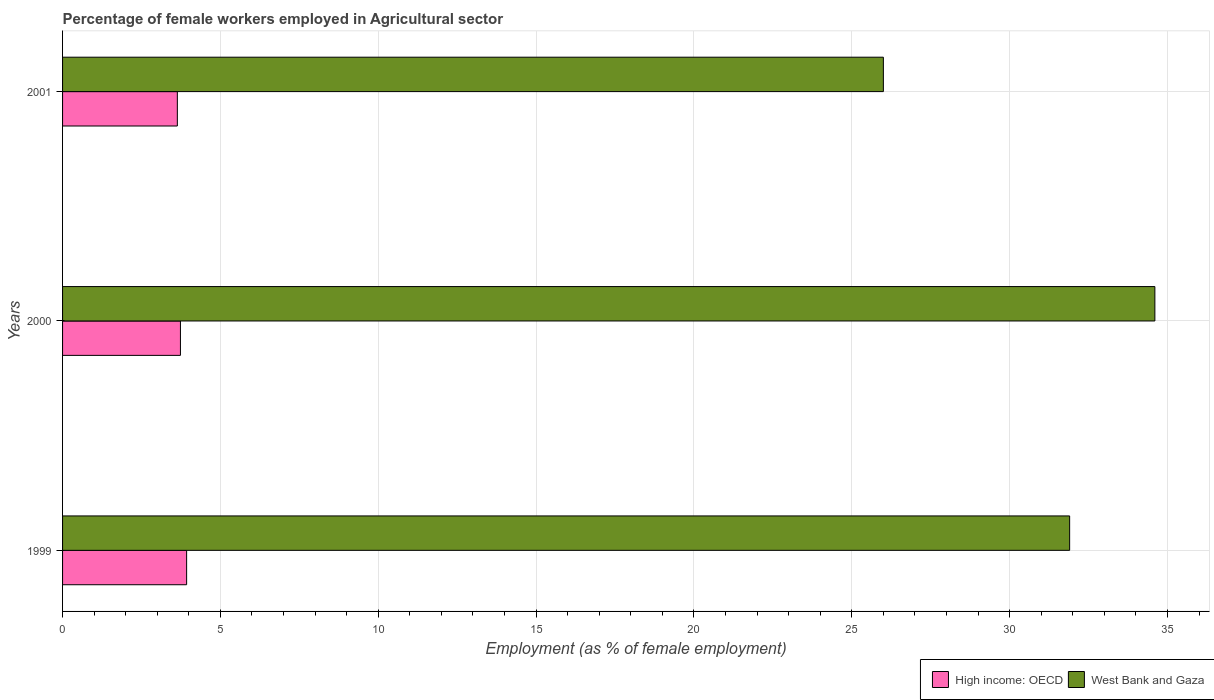How many different coloured bars are there?
Give a very brief answer. 2. Are the number of bars on each tick of the Y-axis equal?
Your answer should be compact. Yes. What is the label of the 1st group of bars from the top?
Make the answer very short. 2001. What is the percentage of females employed in Agricultural sector in High income: OECD in 2000?
Your response must be concise. 3.73. Across all years, what is the maximum percentage of females employed in Agricultural sector in West Bank and Gaza?
Give a very brief answer. 34.6. Across all years, what is the minimum percentage of females employed in Agricultural sector in West Bank and Gaza?
Make the answer very short. 26. In which year was the percentage of females employed in Agricultural sector in West Bank and Gaza maximum?
Make the answer very short. 2000. In which year was the percentage of females employed in Agricultural sector in West Bank and Gaza minimum?
Provide a succinct answer. 2001. What is the total percentage of females employed in Agricultural sector in High income: OECD in the graph?
Make the answer very short. 11.3. What is the difference between the percentage of females employed in Agricultural sector in High income: OECD in 1999 and that in 2000?
Provide a short and direct response. 0.2. What is the difference between the percentage of females employed in Agricultural sector in High income: OECD in 2000 and the percentage of females employed in Agricultural sector in West Bank and Gaza in 2001?
Give a very brief answer. -22.27. What is the average percentage of females employed in Agricultural sector in West Bank and Gaza per year?
Offer a terse response. 30.83. In the year 2000, what is the difference between the percentage of females employed in Agricultural sector in West Bank and Gaza and percentage of females employed in Agricultural sector in High income: OECD?
Your answer should be very brief. 30.87. What is the ratio of the percentage of females employed in Agricultural sector in West Bank and Gaza in 1999 to that in 2001?
Make the answer very short. 1.23. Is the percentage of females employed in Agricultural sector in High income: OECD in 1999 less than that in 2001?
Offer a terse response. No. Is the difference between the percentage of females employed in Agricultural sector in West Bank and Gaza in 1999 and 2001 greater than the difference between the percentage of females employed in Agricultural sector in High income: OECD in 1999 and 2001?
Offer a terse response. Yes. What is the difference between the highest and the second highest percentage of females employed in Agricultural sector in High income: OECD?
Make the answer very short. 0.2. What is the difference between the highest and the lowest percentage of females employed in Agricultural sector in West Bank and Gaza?
Your answer should be compact. 8.6. What does the 2nd bar from the top in 2001 represents?
Offer a very short reply. High income: OECD. What does the 1st bar from the bottom in 1999 represents?
Your answer should be compact. High income: OECD. How many years are there in the graph?
Your answer should be compact. 3. Does the graph contain any zero values?
Your response must be concise. No. Where does the legend appear in the graph?
Provide a short and direct response. Bottom right. How many legend labels are there?
Provide a short and direct response. 2. How are the legend labels stacked?
Give a very brief answer. Horizontal. What is the title of the graph?
Your answer should be very brief. Percentage of female workers employed in Agricultural sector. Does "Nepal" appear as one of the legend labels in the graph?
Give a very brief answer. No. What is the label or title of the X-axis?
Your response must be concise. Employment (as % of female employment). What is the Employment (as % of female employment) in High income: OECD in 1999?
Ensure brevity in your answer.  3.93. What is the Employment (as % of female employment) in West Bank and Gaza in 1999?
Keep it short and to the point. 31.9. What is the Employment (as % of female employment) in High income: OECD in 2000?
Offer a terse response. 3.73. What is the Employment (as % of female employment) of West Bank and Gaza in 2000?
Keep it short and to the point. 34.6. What is the Employment (as % of female employment) of High income: OECD in 2001?
Provide a short and direct response. 3.64. Across all years, what is the maximum Employment (as % of female employment) in High income: OECD?
Give a very brief answer. 3.93. Across all years, what is the maximum Employment (as % of female employment) in West Bank and Gaza?
Your response must be concise. 34.6. Across all years, what is the minimum Employment (as % of female employment) of High income: OECD?
Offer a terse response. 3.64. What is the total Employment (as % of female employment) of High income: OECD in the graph?
Provide a short and direct response. 11.3. What is the total Employment (as % of female employment) of West Bank and Gaza in the graph?
Give a very brief answer. 92.5. What is the difference between the Employment (as % of female employment) of High income: OECD in 1999 and that in 2000?
Provide a succinct answer. 0.2. What is the difference between the Employment (as % of female employment) of High income: OECD in 1999 and that in 2001?
Offer a terse response. 0.29. What is the difference between the Employment (as % of female employment) in High income: OECD in 2000 and that in 2001?
Your answer should be compact. 0.1. What is the difference between the Employment (as % of female employment) in West Bank and Gaza in 2000 and that in 2001?
Provide a short and direct response. 8.6. What is the difference between the Employment (as % of female employment) of High income: OECD in 1999 and the Employment (as % of female employment) of West Bank and Gaza in 2000?
Offer a terse response. -30.67. What is the difference between the Employment (as % of female employment) of High income: OECD in 1999 and the Employment (as % of female employment) of West Bank and Gaza in 2001?
Your answer should be very brief. -22.07. What is the difference between the Employment (as % of female employment) in High income: OECD in 2000 and the Employment (as % of female employment) in West Bank and Gaza in 2001?
Your answer should be very brief. -22.27. What is the average Employment (as % of female employment) in High income: OECD per year?
Your answer should be compact. 3.77. What is the average Employment (as % of female employment) in West Bank and Gaza per year?
Provide a succinct answer. 30.83. In the year 1999, what is the difference between the Employment (as % of female employment) of High income: OECD and Employment (as % of female employment) of West Bank and Gaza?
Provide a succinct answer. -27.97. In the year 2000, what is the difference between the Employment (as % of female employment) of High income: OECD and Employment (as % of female employment) of West Bank and Gaza?
Your answer should be compact. -30.87. In the year 2001, what is the difference between the Employment (as % of female employment) in High income: OECD and Employment (as % of female employment) in West Bank and Gaza?
Give a very brief answer. -22.36. What is the ratio of the Employment (as % of female employment) of High income: OECD in 1999 to that in 2000?
Provide a short and direct response. 1.05. What is the ratio of the Employment (as % of female employment) in West Bank and Gaza in 1999 to that in 2000?
Offer a terse response. 0.92. What is the ratio of the Employment (as % of female employment) of High income: OECD in 1999 to that in 2001?
Give a very brief answer. 1.08. What is the ratio of the Employment (as % of female employment) of West Bank and Gaza in 1999 to that in 2001?
Your response must be concise. 1.23. What is the ratio of the Employment (as % of female employment) of High income: OECD in 2000 to that in 2001?
Ensure brevity in your answer.  1.03. What is the ratio of the Employment (as % of female employment) in West Bank and Gaza in 2000 to that in 2001?
Your response must be concise. 1.33. What is the difference between the highest and the second highest Employment (as % of female employment) of High income: OECD?
Give a very brief answer. 0.2. What is the difference between the highest and the lowest Employment (as % of female employment) of High income: OECD?
Offer a terse response. 0.29. 